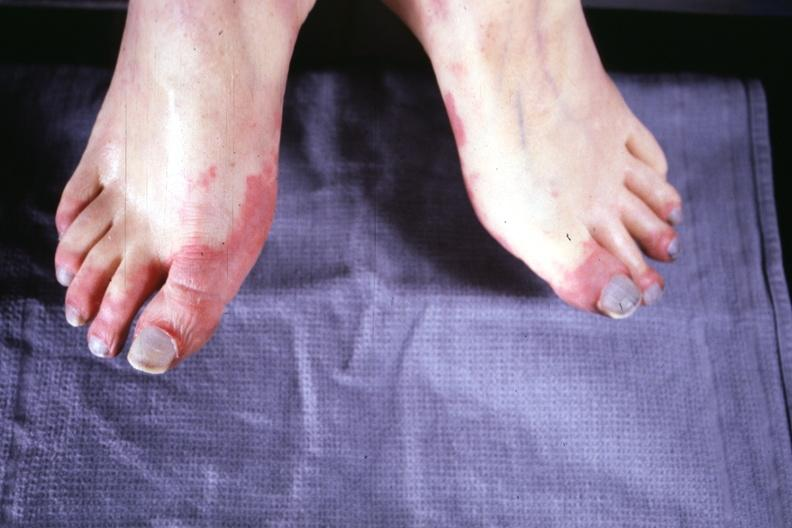what does this image show?
Answer the question using a single word or phrase. Early lesion with erythematous appearance 